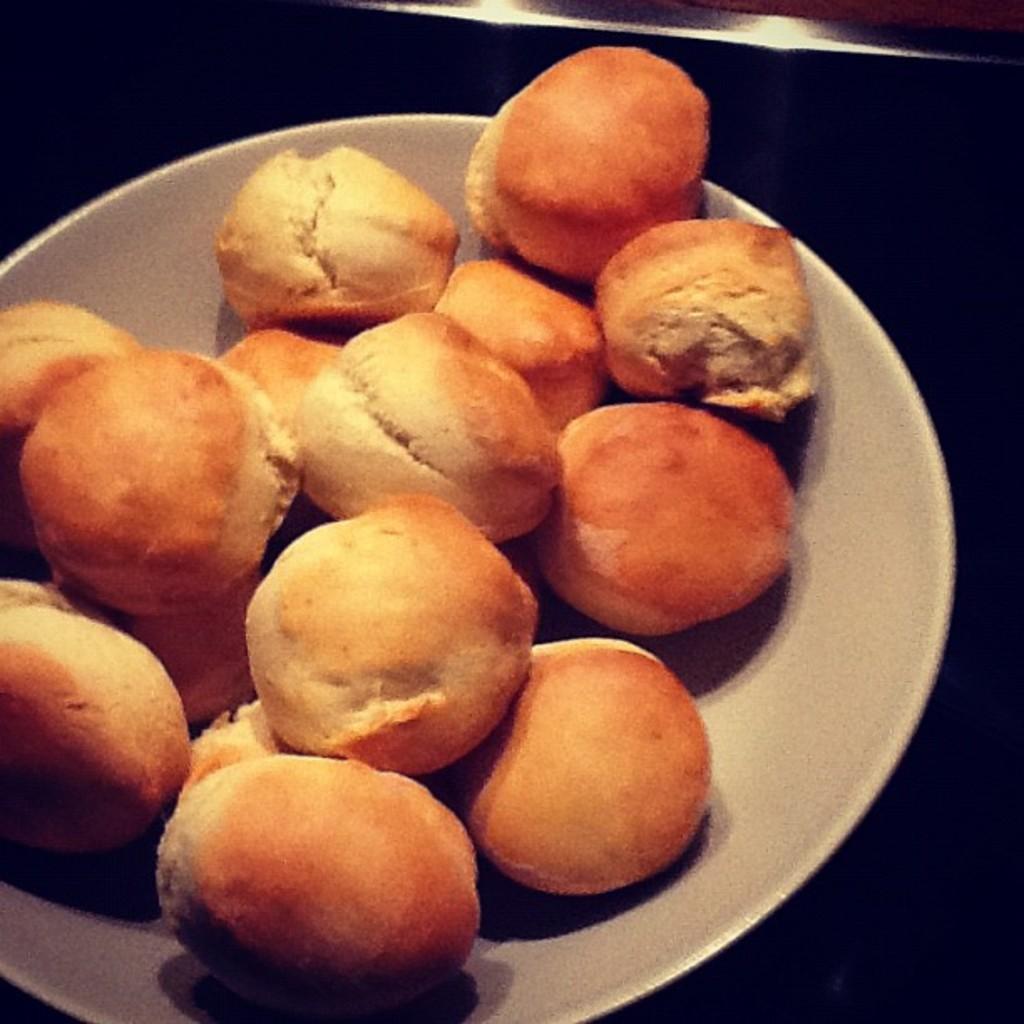Can you describe this image briefly? In this picture we can see a plate, there is some food present in this place, we can see a dark background. 